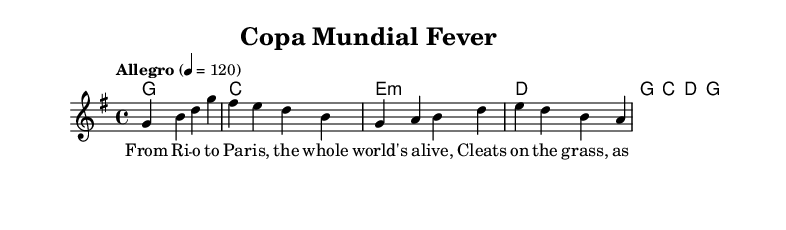What is the key signature of this music? The key signature is G major, which has one sharp (F#). This can be determined by looking at the key signature indicated at the beginning of the score.
Answer: G major What is the time signature of this music? The time signature is 4/4, indicated at the beginning of the score. This means there are four beats in each measure and a quarter note gets one beat.
Answer: 4/4 What is the tempo marking for this music? The tempo marking is "Allegro," with a metronome marking of 120. This indicates a fast and lively pace for the performance.
Answer: Allegro How many measures are in the melody section? The melody section contains four measures, which can be counted by the number of vertical lines separating the measures in the notation.
Answer: 4 What type of musical style is represented by the song? The song is identified as "Country Rock," which is evident from the genre's characteristics including upbeat rhythms and themes related to Americana and storytelling found in the lyrics.
Answer: Country Rock What is the main lyrical theme of the chorus? The main lyrical theme of the chorus expresses the passion and excitement surrounding the "Copa Mundial" and the celebration of women's soccer. This can be inferred from the lyrics that emphasize the event and the efforts of the players.
Answer: Copa Mundial Fever What chords are used in the first measure? The chord used in the first measure is G major. This can be determined by looking at the chord symbols above the melody.
Answer: G 